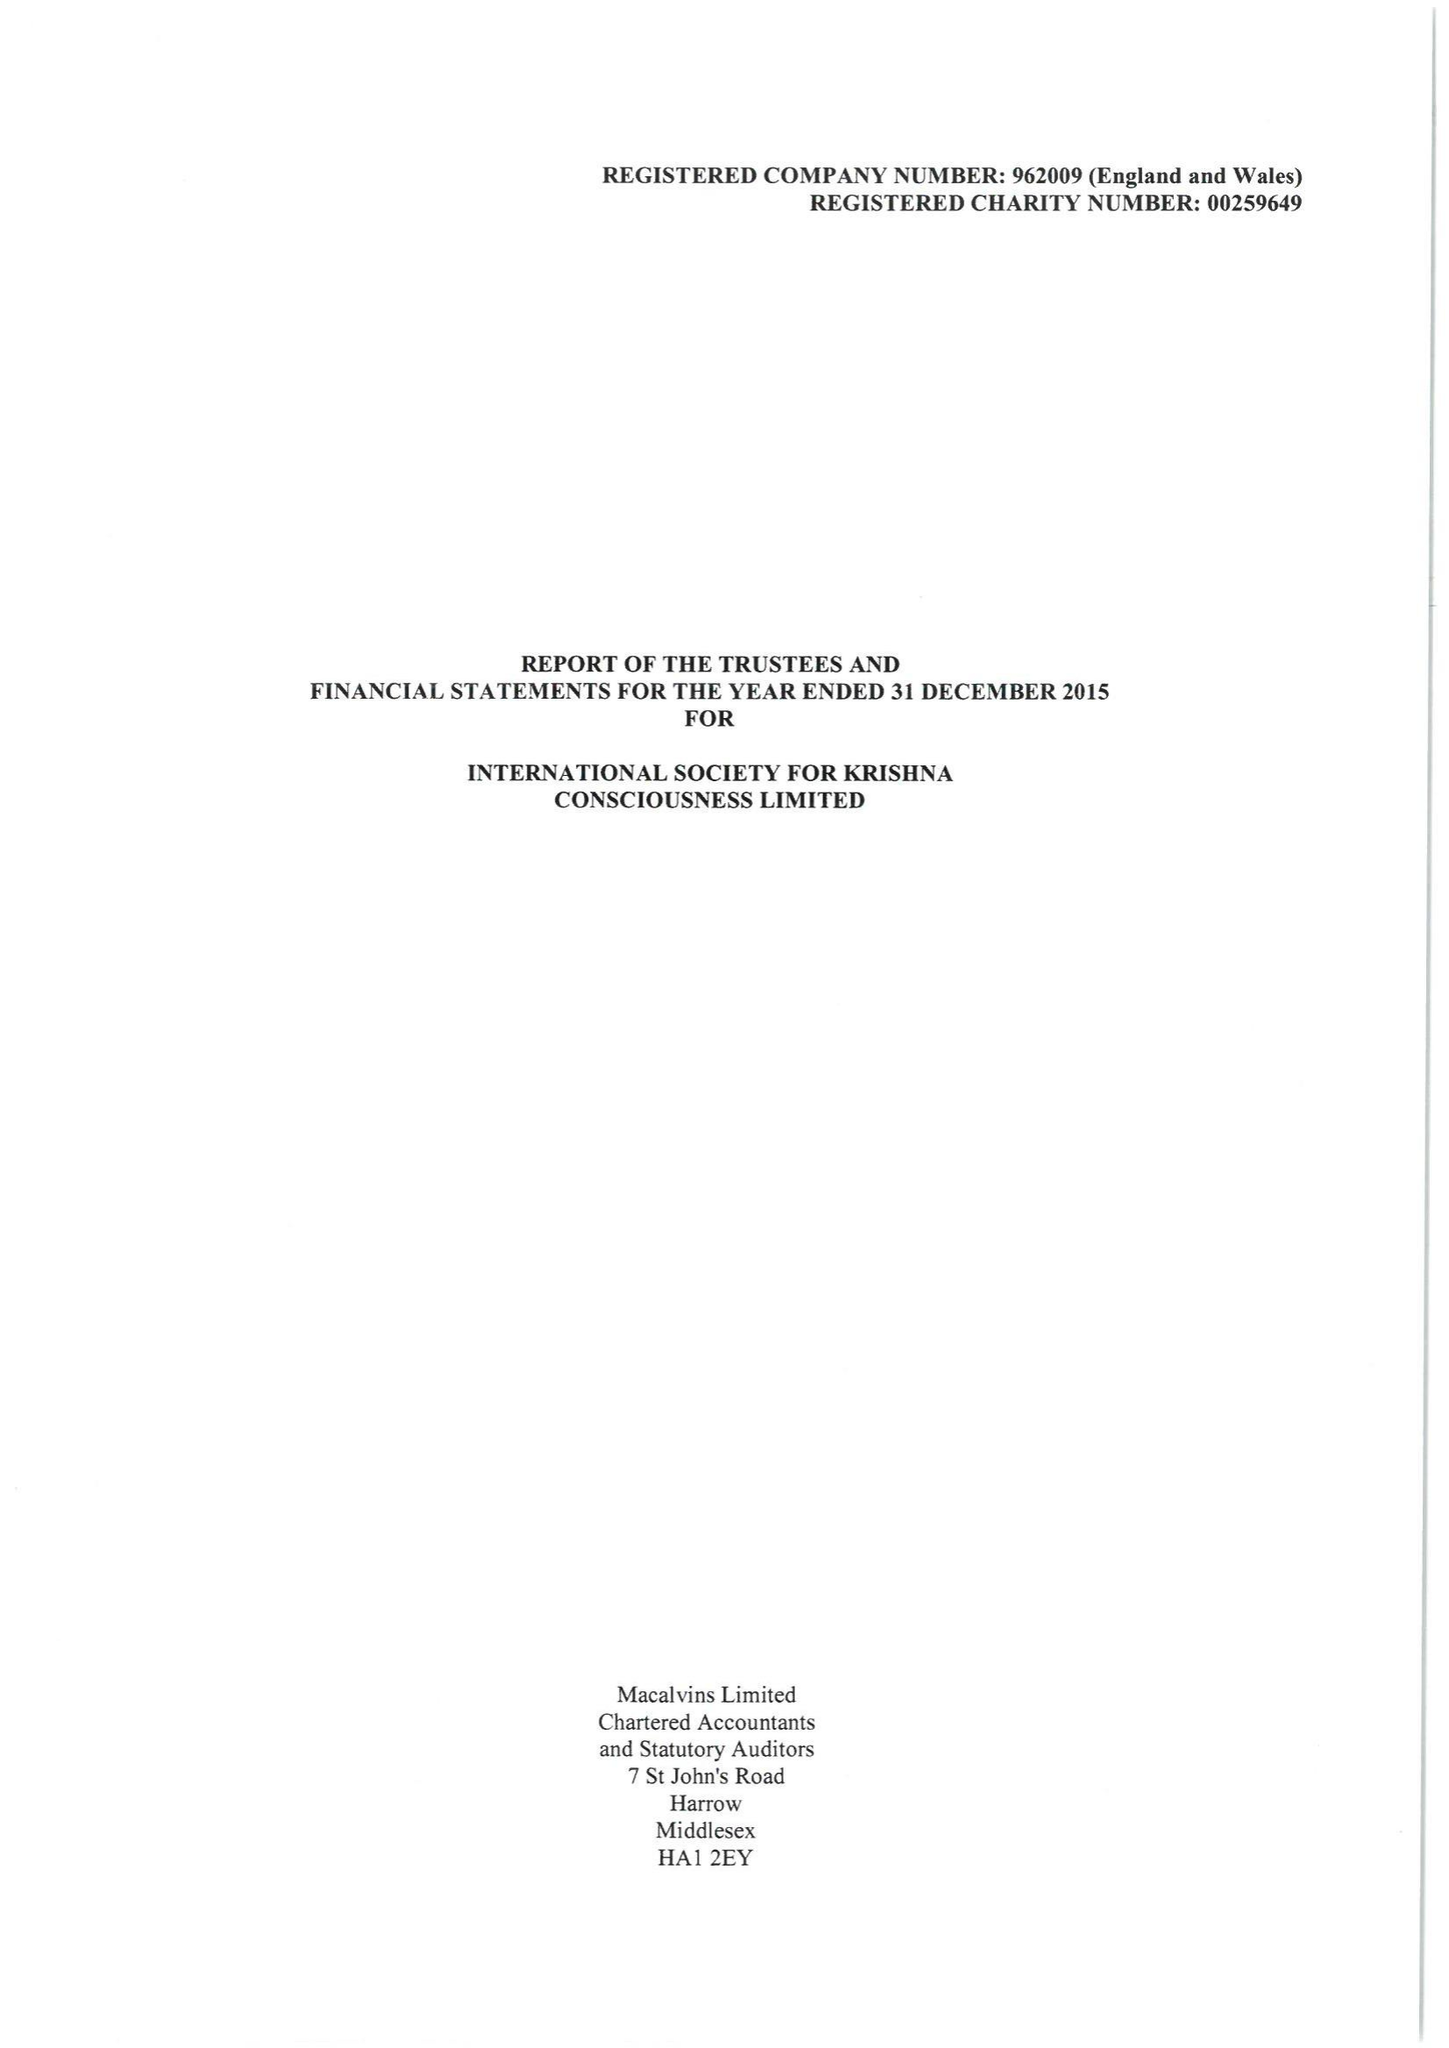What is the value for the charity_number?
Answer the question using a single word or phrase. 259649 